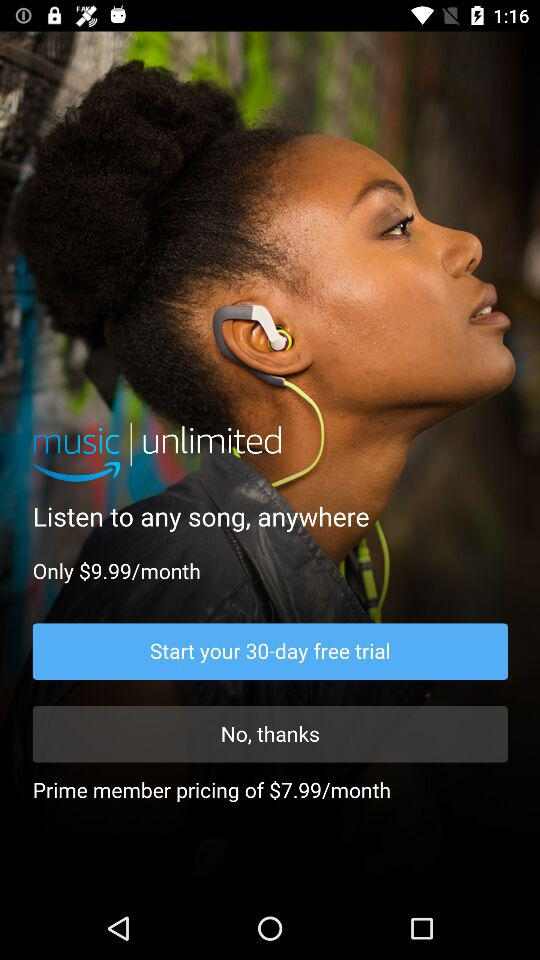What is the subscription price for a month? The subscription prices for a month are $9.99 and $7.99. 